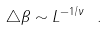<formula> <loc_0><loc_0><loc_500><loc_500>\triangle \beta \sim L ^ { - 1 / \nu } \ .</formula> 